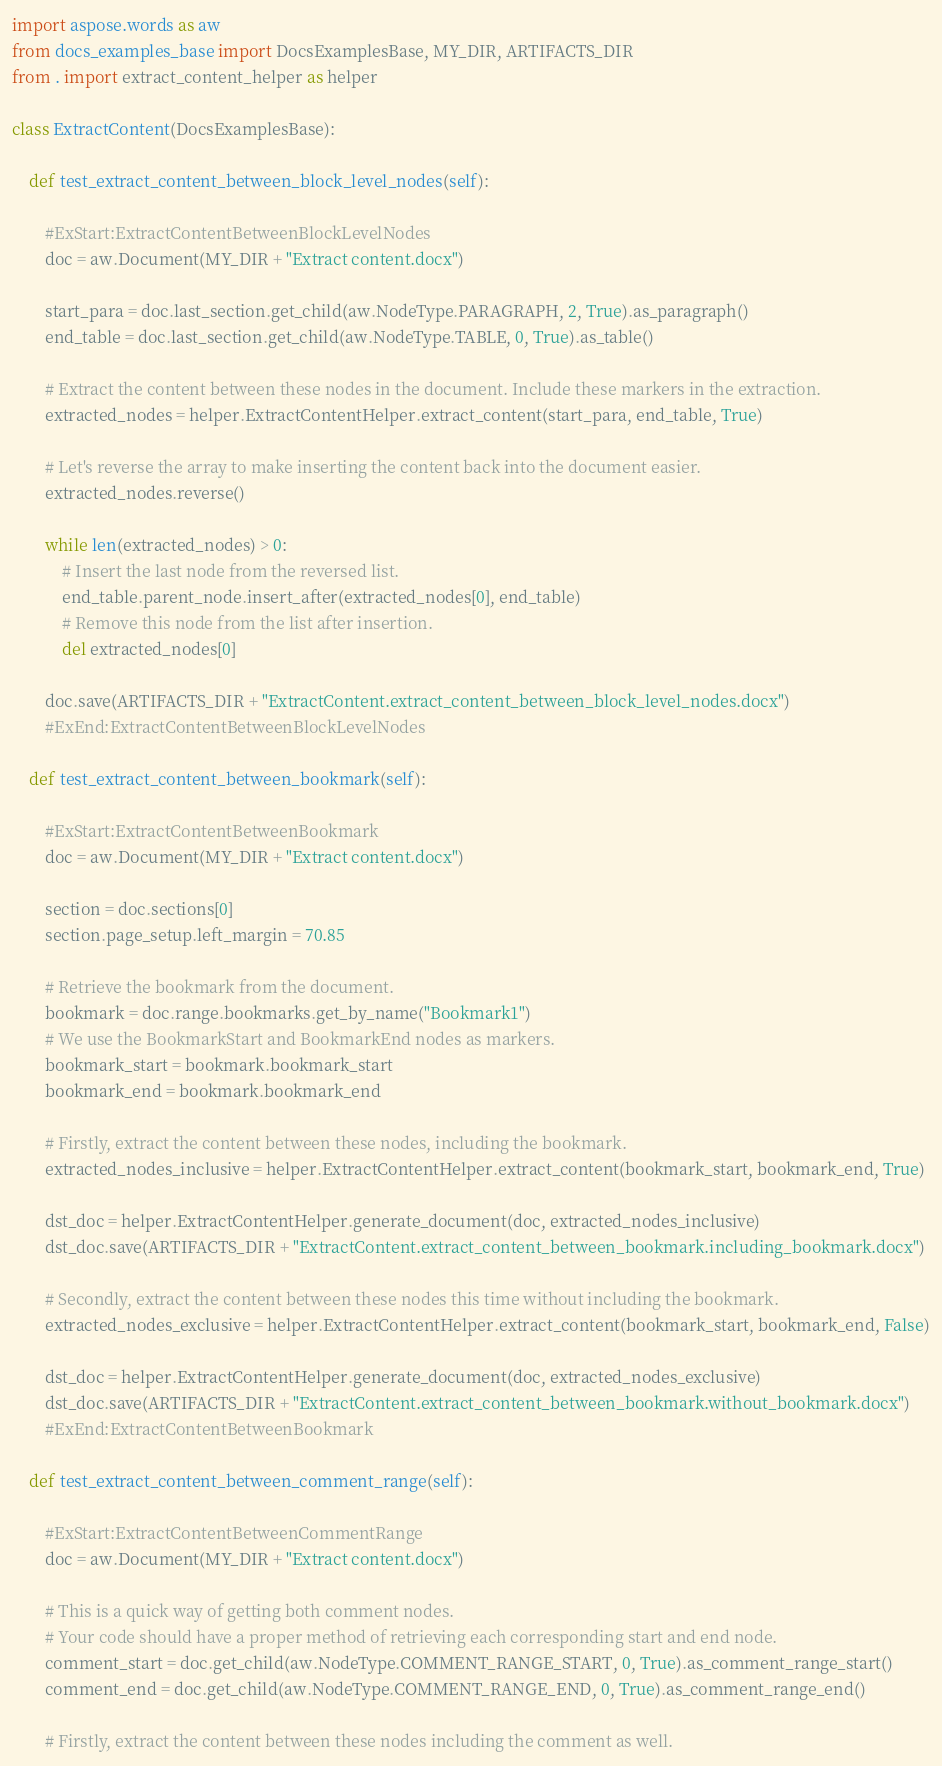<code> <loc_0><loc_0><loc_500><loc_500><_Python_>import aspose.words as aw
from docs_examples_base import DocsExamplesBase, MY_DIR, ARTIFACTS_DIR
from . import extract_content_helper as helper

class ExtractContent(DocsExamplesBase):

    def test_extract_content_between_block_level_nodes(self):

        #ExStart:ExtractContentBetweenBlockLevelNodes
        doc = aw.Document(MY_DIR + "Extract content.docx")

        start_para = doc.last_section.get_child(aw.NodeType.PARAGRAPH, 2, True).as_paragraph()
        end_table = doc.last_section.get_child(aw.NodeType.TABLE, 0, True).as_table()

        # Extract the content between these nodes in the document. Include these markers in the extraction.
        extracted_nodes = helper.ExtractContentHelper.extract_content(start_para, end_table, True)

        # Let's reverse the array to make inserting the content back into the document easier.
        extracted_nodes.reverse()

        while len(extracted_nodes) > 0:
            # Insert the last node from the reversed list.
            end_table.parent_node.insert_after(extracted_nodes[0], end_table)
            # Remove this node from the list after insertion.
            del extracted_nodes[0]

        doc.save(ARTIFACTS_DIR + "ExtractContent.extract_content_between_block_level_nodes.docx")
        #ExEnd:ExtractContentBetweenBlockLevelNodes

    def test_extract_content_between_bookmark(self):

        #ExStart:ExtractContentBetweenBookmark
        doc = aw.Document(MY_DIR + "Extract content.docx")

        section = doc.sections[0]
        section.page_setup.left_margin = 70.85

        # Retrieve the bookmark from the document.
        bookmark = doc.range.bookmarks.get_by_name("Bookmark1")
        # We use the BookmarkStart and BookmarkEnd nodes as markers.
        bookmark_start = bookmark.bookmark_start
        bookmark_end = bookmark.bookmark_end

        # Firstly, extract the content between these nodes, including the bookmark.
        extracted_nodes_inclusive = helper.ExtractContentHelper.extract_content(bookmark_start, bookmark_end, True)

        dst_doc = helper.ExtractContentHelper.generate_document(doc, extracted_nodes_inclusive)
        dst_doc.save(ARTIFACTS_DIR + "ExtractContent.extract_content_between_bookmark.including_bookmark.docx")

        # Secondly, extract the content between these nodes this time without including the bookmark.
        extracted_nodes_exclusive = helper.ExtractContentHelper.extract_content(bookmark_start, bookmark_end, False)

        dst_doc = helper.ExtractContentHelper.generate_document(doc, extracted_nodes_exclusive)
        dst_doc.save(ARTIFACTS_DIR + "ExtractContent.extract_content_between_bookmark.without_bookmark.docx")
        #ExEnd:ExtractContentBetweenBookmark

    def test_extract_content_between_comment_range(self):

        #ExStart:ExtractContentBetweenCommentRange
        doc = aw.Document(MY_DIR + "Extract content.docx")

        # This is a quick way of getting both comment nodes.
        # Your code should have a proper method of retrieving each corresponding start and end node.
        comment_start = doc.get_child(aw.NodeType.COMMENT_RANGE_START, 0, True).as_comment_range_start()
        comment_end = doc.get_child(aw.NodeType.COMMENT_RANGE_END, 0, True).as_comment_range_end()

        # Firstly, extract the content between these nodes including the comment as well.</code> 